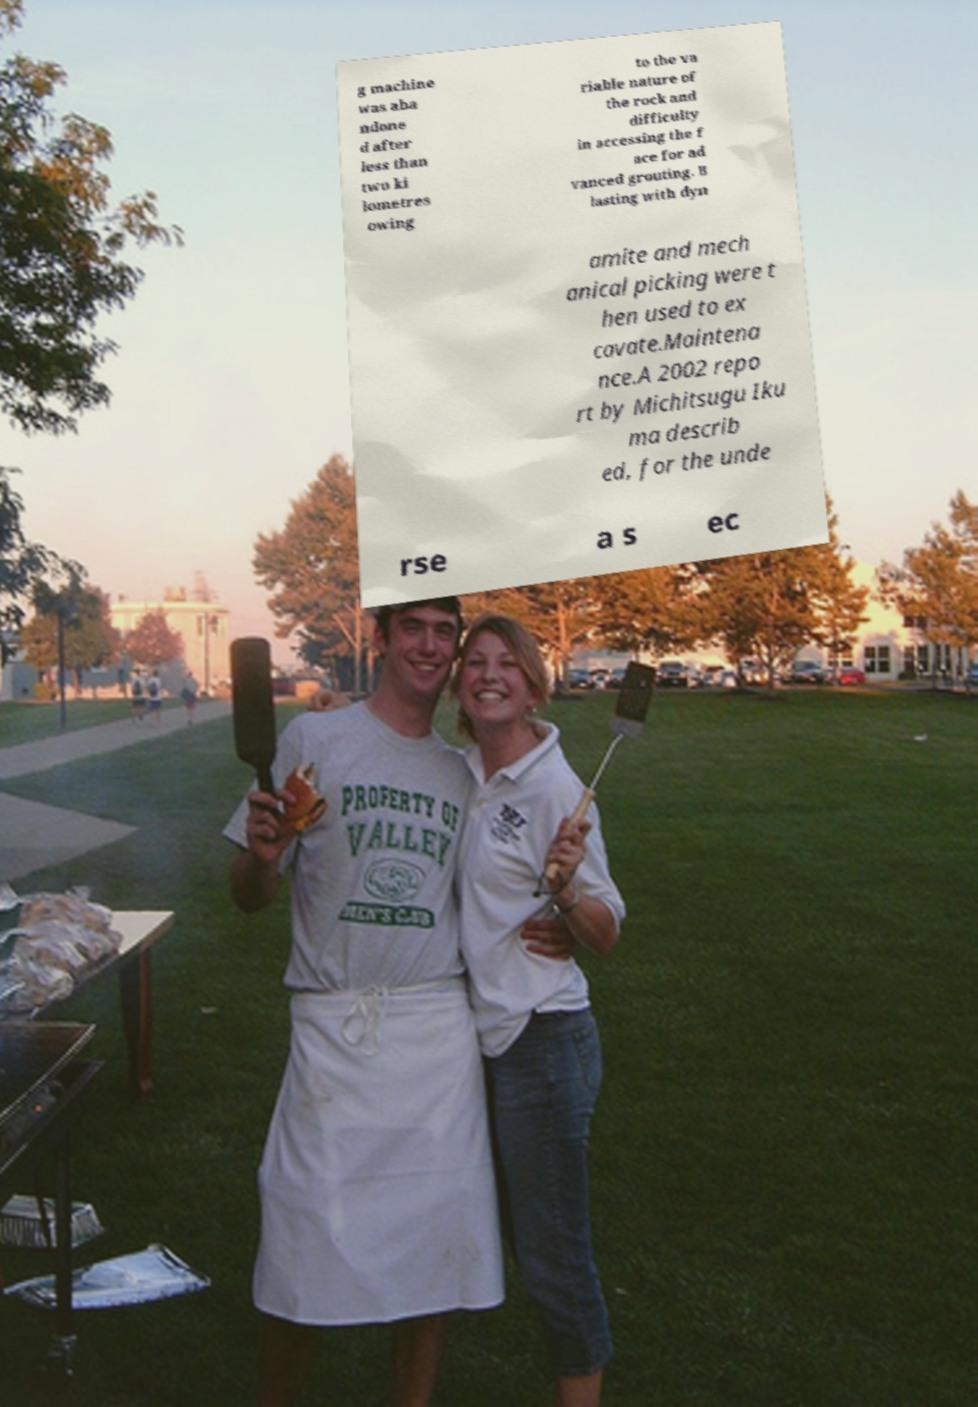Please identify and transcribe the text found in this image. g machine was aba ndone d after less than two ki lometres owing to the va riable nature of the rock and difficulty in accessing the f ace for ad vanced grouting. B lasting with dyn amite and mech anical picking were t hen used to ex cavate.Maintena nce.A 2002 repo rt by Michitsugu Iku ma describ ed, for the unde rse a s ec 